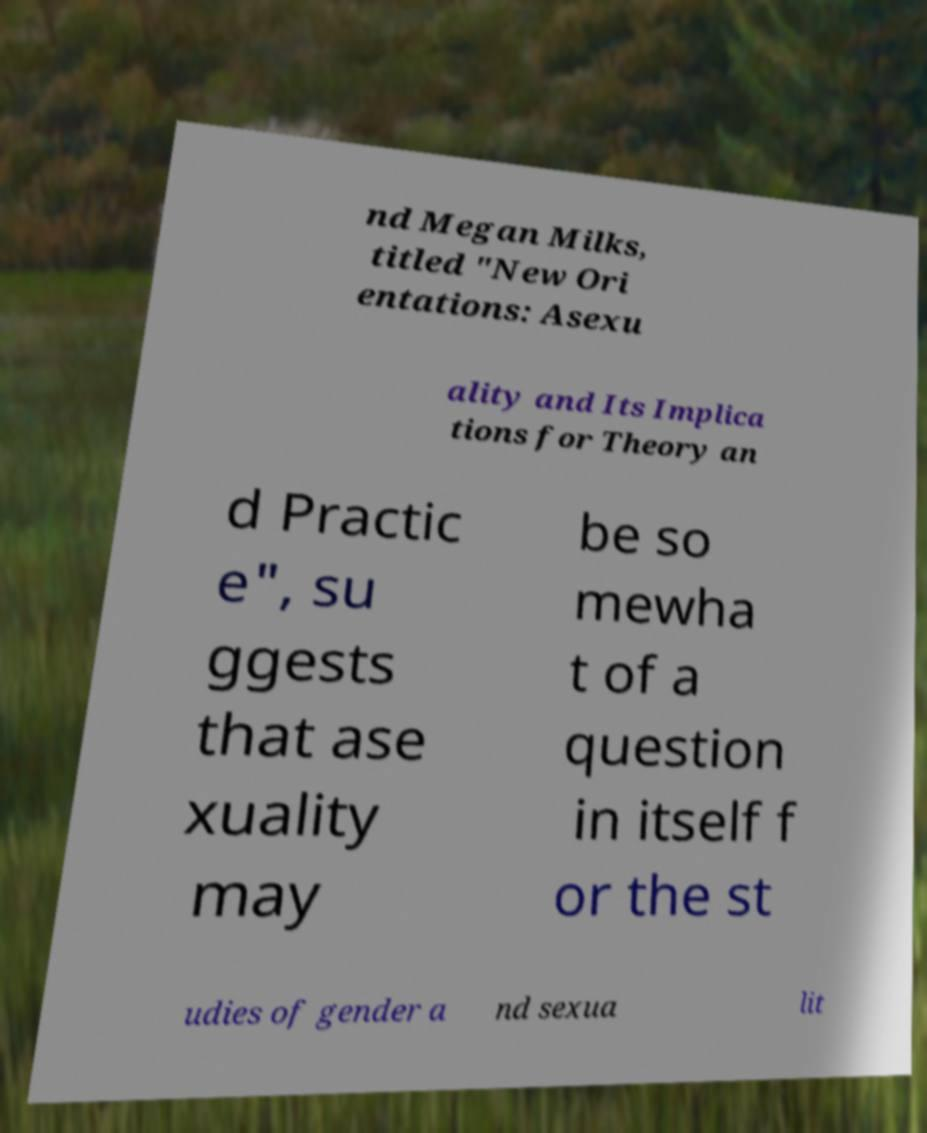Can you read and provide the text displayed in the image?This photo seems to have some interesting text. Can you extract and type it out for me? nd Megan Milks, titled "New Ori entations: Asexu ality and Its Implica tions for Theory an d Practic e", su ggests that ase xuality may be so mewha t of a question in itself f or the st udies of gender a nd sexua lit 